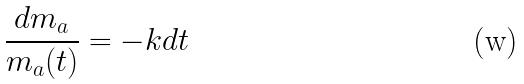<formula> <loc_0><loc_0><loc_500><loc_500>\frac { d m _ { a } } { m _ { a } ( t ) } = - k d t</formula> 